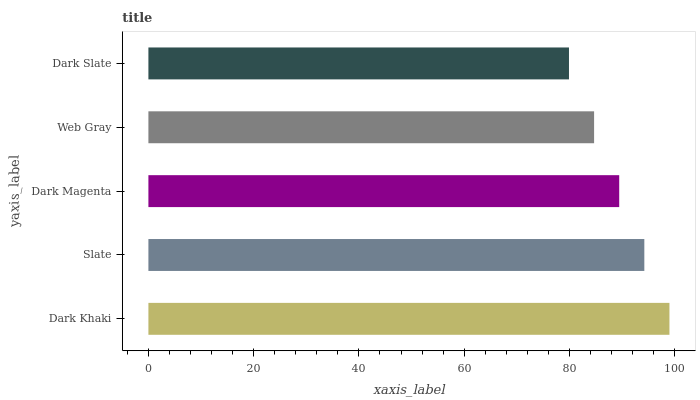Is Dark Slate the minimum?
Answer yes or no. Yes. Is Dark Khaki the maximum?
Answer yes or no. Yes. Is Slate the minimum?
Answer yes or no. No. Is Slate the maximum?
Answer yes or no. No. Is Dark Khaki greater than Slate?
Answer yes or no. Yes. Is Slate less than Dark Khaki?
Answer yes or no. Yes. Is Slate greater than Dark Khaki?
Answer yes or no. No. Is Dark Khaki less than Slate?
Answer yes or no. No. Is Dark Magenta the high median?
Answer yes or no. Yes. Is Dark Magenta the low median?
Answer yes or no. Yes. Is Slate the high median?
Answer yes or no. No. Is Dark Khaki the low median?
Answer yes or no. No. 